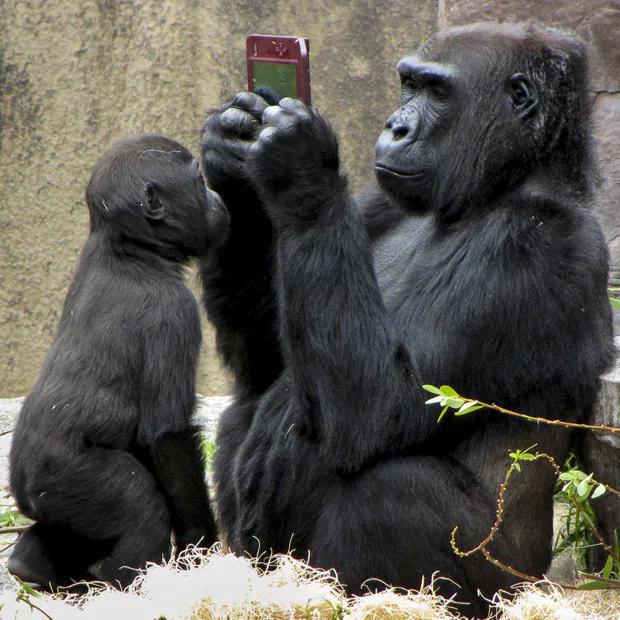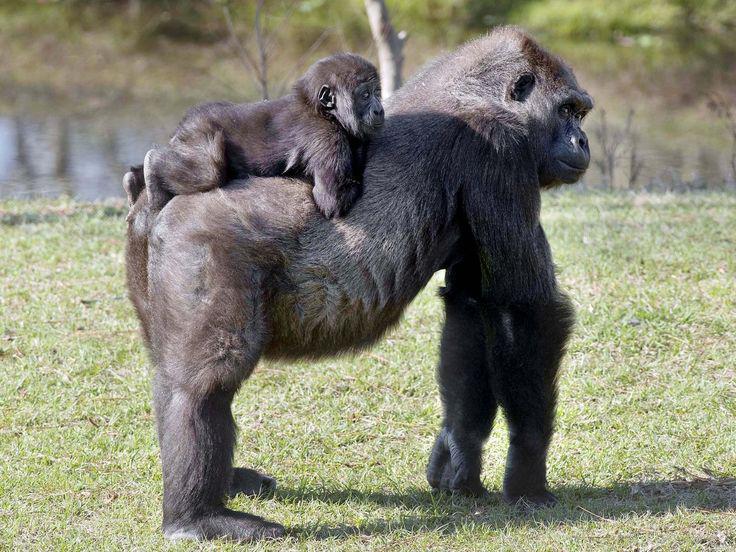The first image is the image on the left, the second image is the image on the right. Evaluate the accuracy of this statement regarding the images: "A baby monkey is riding on an adult in the image on the right.". Is it true? Answer yes or no. Yes. 